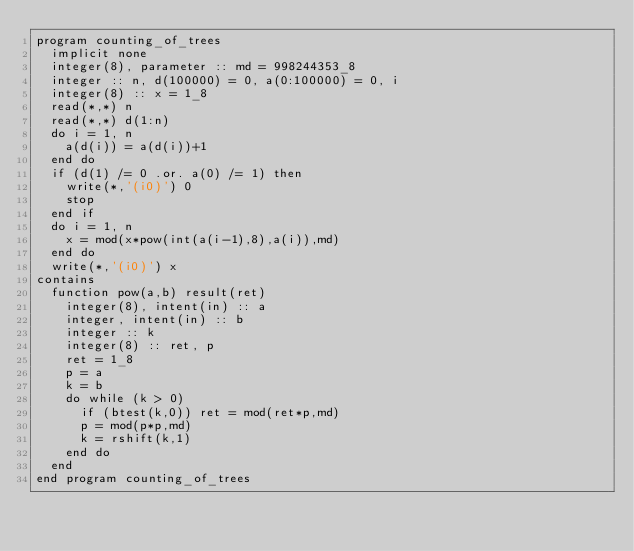Convert code to text. <code><loc_0><loc_0><loc_500><loc_500><_FORTRAN_>program counting_of_trees
  implicit none
  integer(8), parameter :: md = 998244353_8
  integer :: n, d(100000) = 0, a(0:100000) = 0, i
  integer(8) :: x = 1_8
  read(*,*) n
  read(*,*) d(1:n)
  do i = 1, n
    a(d(i)) = a(d(i))+1
  end do
  if (d(1) /= 0 .or. a(0) /= 1) then
    write(*,'(i0)') 0
    stop
  end if
  do i = 1, n
    x = mod(x*pow(int(a(i-1),8),a(i)),md)
  end do
  write(*,'(i0)') x
contains
  function pow(a,b) result(ret)
    integer(8), intent(in) :: a
    integer, intent(in) :: b
    integer :: k
    integer(8) :: ret, p
    ret = 1_8
    p = a
    k = b
    do while (k > 0)
      if (btest(k,0)) ret = mod(ret*p,md)
      p = mod(p*p,md)
      k = rshift(k,1)
    end do
  end
end program counting_of_trees</code> 